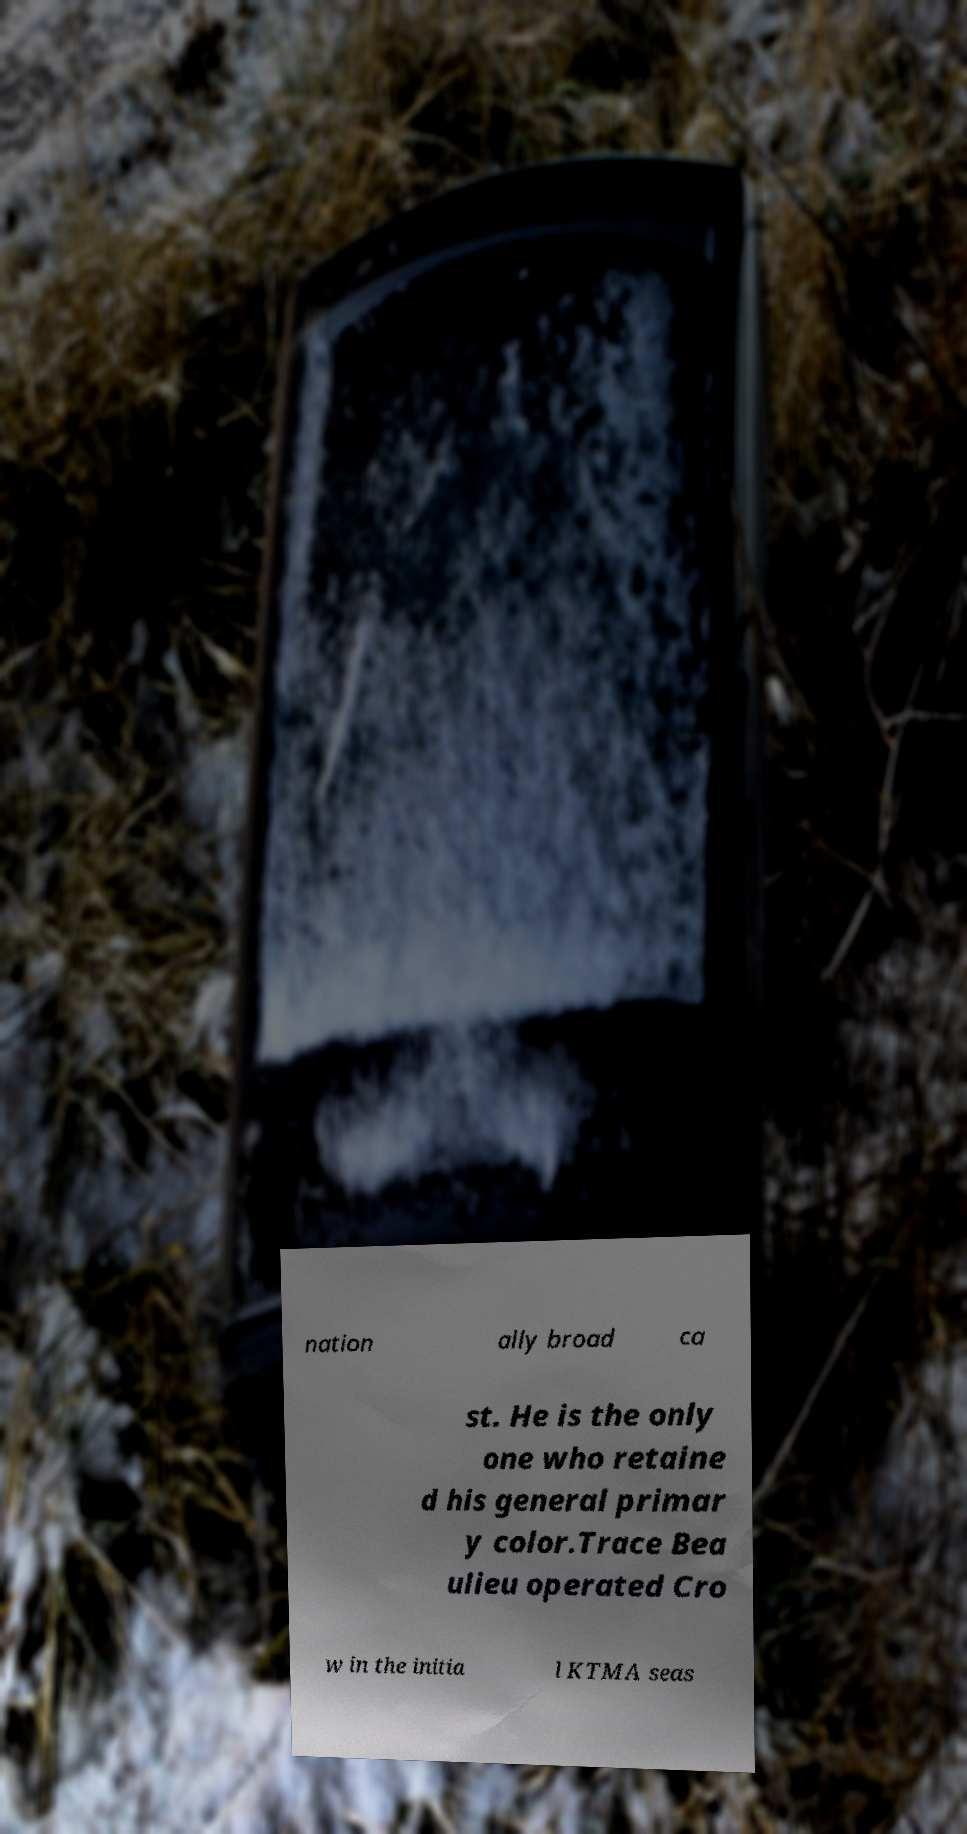Can you accurately transcribe the text from the provided image for me? nation ally broad ca st. He is the only one who retaine d his general primar y color.Trace Bea ulieu operated Cro w in the initia l KTMA seas 